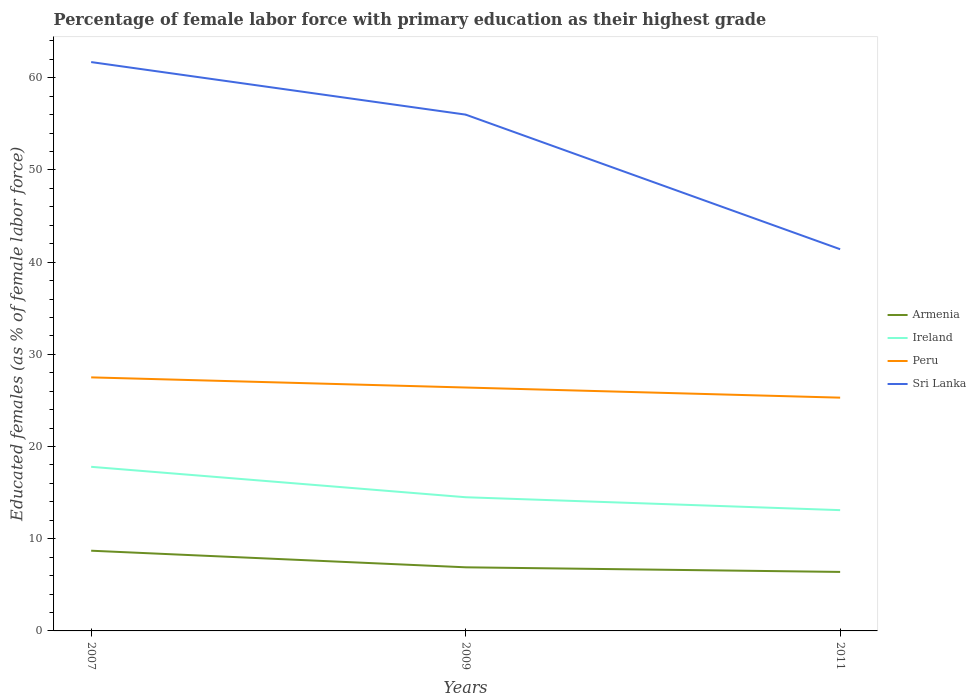Is the number of lines equal to the number of legend labels?
Your answer should be very brief. Yes. Across all years, what is the maximum percentage of female labor force with primary education in Ireland?
Provide a short and direct response. 13.1. What is the total percentage of female labor force with primary education in Sri Lanka in the graph?
Your answer should be very brief. 14.6. What is the difference between the highest and the second highest percentage of female labor force with primary education in Sri Lanka?
Your response must be concise. 20.3. How many years are there in the graph?
Offer a very short reply. 3. What is the difference between two consecutive major ticks on the Y-axis?
Provide a short and direct response. 10. Are the values on the major ticks of Y-axis written in scientific E-notation?
Your answer should be compact. No. Where does the legend appear in the graph?
Give a very brief answer. Center right. How are the legend labels stacked?
Make the answer very short. Vertical. What is the title of the graph?
Offer a terse response. Percentage of female labor force with primary education as their highest grade. Does "Somalia" appear as one of the legend labels in the graph?
Your answer should be compact. No. What is the label or title of the X-axis?
Ensure brevity in your answer.  Years. What is the label or title of the Y-axis?
Ensure brevity in your answer.  Educated females (as % of female labor force). What is the Educated females (as % of female labor force) in Armenia in 2007?
Offer a terse response. 8.7. What is the Educated females (as % of female labor force) of Ireland in 2007?
Ensure brevity in your answer.  17.8. What is the Educated females (as % of female labor force) of Peru in 2007?
Offer a terse response. 27.5. What is the Educated females (as % of female labor force) of Sri Lanka in 2007?
Provide a succinct answer. 61.7. What is the Educated females (as % of female labor force) in Armenia in 2009?
Offer a very short reply. 6.9. What is the Educated females (as % of female labor force) of Peru in 2009?
Your answer should be compact. 26.4. What is the Educated females (as % of female labor force) of Armenia in 2011?
Offer a very short reply. 6.4. What is the Educated females (as % of female labor force) in Ireland in 2011?
Provide a succinct answer. 13.1. What is the Educated females (as % of female labor force) of Peru in 2011?
Give a very brief answer. 25.3. What is the Educated females (as % of female labor force) in Sri Lanka in 2011?
Your response must be concise. 41.4. Across all years, what is the maximum Educated females (as % of female labor force) of Armenia?
Your response must be concise. 8.7. Across all years, what is the maximum Educated females (as % of female labor force) of Ireland?
Provide a short and direct response. 17.8. Across all years, what is the maximum Educated females (as % of female labor force) of Peru?
Make the answer very short. 27.5. Across all years, what is the maximum Educated females (as % of female labor force) in Sri Lanka?
Provide a short and direct response. 61.7. Across all years, what is the minimum Educated females (as % of female labor force) in Armenia?
Give a very brief answer. 6.4. Across all years, what is the minimum Educated females (as % of female labor force) of Ireland?
Make the answer very short. 13.1. Across all years, what is the minimum Educated females (as % of female labor force) of Peru?
Offer a terse response. 25.3. Across all years, what is the minimum Educated females (as % of female labor force) of Sri Lanka?
Keep it short and to the point. 41.4. What is the total Educated females (as % of female labor force) of Ireland in the graph?
Your response must be concise. 45.4. What is the total Educated females (as % of female labor force) of Peru in the graph?
Ensure brevity in your answer.  79.2. What is the total Educated females (as % of female labor force) in Sri Lanka in the graph?
Offer a very short reply. 159.1. What is the difference between the Educated females (as % of female labor force) in Armenia in 2007 and that in 2009?
Offer a terse response. 1.8. What is the difference between the Educated females (as % of female labor force) in Armenia in 2007 and that in 2011?
Your answer should be very brief. 2.3. What is the difference between the Educated females (as % of female labor force) in Ireland in 2007 and that in 2011?
Your answer should be very brief. 4.7. What is the difference between the Educated females (as % of female labor force) in Peru in 2007 and that in 2011?
Your answer should be compact. 2.2. What is the difference between the Educated females (as % of female labor force) in Sri Lanka in 2007 and that in 2011?
Provide a succinct answer. 20.3. What is the difference between the Educated females (as % of female labor force) of Armenia in 2009 and that in 2011?
Your answer should be compact. 0.5. What is the difference between the Educated females (as % of female labor force) in Peru in 2009 and that in 2011?
Give a very brief answer. 1.1. What is the difference between the Educated females (as % of female labor force) of Armenia in 2007 and the Educated females (as % of female labor force) of Peru in 2009?
Your answer should be compact. -17.7. What is the difference between the Educated females (as % of female labor force) of Armenia in 2007 and the Educated females (as % of female labor force) of Sri Lanka in 2009?
Make the answer very short. -47.3. What is the difference between the Educated females (as % of female labor force) in Ireland in 2007 and the Educated females (as % of female labor force) in Peru in 2009?
Offer a very short reply. -8.6. What is the difference between the Educated females (as % of female labor force) in Ireland in 2007 and the Educated females (as % of female labor force) in Sri Lanka in 2009?
Your answer should be very brief. -38.2. What is the difference between the Educated females (as % of female labor force) in Peru in 2007 and the Educated females (as % of female labor force) in Sri Lanka in 2009?
Ensure brevity in your answer.  -28.5. What is the difference between the Educated females (as % of female labor force) in Armenia in 2007 and the Educated females (as % of female labor force) in Ireland in 2011?
Provide a short and direct response. -4.4. What is the difference between the Educated females (as % of female labor force) in Armenia in 2007 and the Educated females (as % of female labor force) in Peru in 2011?
Provide a short and direct response. -16.6. What is the difference between the Educated females (as % of female labor force) of Armenia in 2007 and the Educated females (as % of female labor force) of Sri Lanka in 2011?
Provide a succinct answer. -32.7. What is the difference between the Educated females (as % of female labor force) of Ireland in 2007 and the Educated females (as % of female labor force) of Peru in 2011?
Give a very brief answer. -7.5. What is the difference between the Educated females (as % of female labor force) of Ireland in 2007 and the Educated females (as % of female labor force) of Sri Lanka in 2011?
Ensure brevity in your answer.  -23.6. What is the difference between the Educated females (as % of female labor force) in Armenia in 2009 and the Educated females (as % of female labor force) in Peru in 2011?
Your answer should be very brief. -18.4. What is the difference between the Educated females (as % of female labor force) of Armenia in 2009 and the Educated females (as % of female labor force) of Sri Lanka in 2011?
Make the answer very short. -34.5. What is the difference between the Educated females (as % of female labor force) of Ireland in 2009 and the Educated females (as % of female labor force) of Peru in 2011?
Ensure brevity in your answer.  -10.8. What is the difference between the Educated females (as % of female labor force) of Ireland in 2009 and the Educated females (as % of female labor force) of Sri Lanka in 2011?
Keep it short and to the point. -26.9. What is the average Educated females (as % of female labor force) of Armenia per year?
Keep it short and to the point. 7.33. What is the average Educated females (as % of female labor force) in Ireland per year?
Your answer should be very brief. 15.13. What is the average Educated females (as % of female labor force) in Peru per year?
Give a very brief answer. 26.4. What is the average Educated females (as % of female labor force) of Sri Lanka per year?
Keep it short and to the point. 53.03. In the year 2007, what is the difference between the Educated females (as % of female labor force) in Armenia and Educated females (as % of female labor force) in Ireland?
Give a very brief answer. -9.1. In the year 2007, what is the difference between the Educated females (as % of female labor force) of Armenia and Educated females (as % of female labor force) of Peru?
Your response must be concise. -18.8. In the year 2007, what is the difference between the Educated females (as % of female labor force) of Armenia and Educated females (as % of female labor force) of Sri Lanka?
Keep it short and to the point. -53. In the year 2007, what is the difference between the Educated females (as % of female labor force) of Ireland and Educated females (as % of female labor force) of Peru?
Provide a succinct answer. -9.7. In the year 2007, what is the difference between the Educated females (as % of female labor force) of Ireland and Educated females (as % of female labor force) of Sri Lanka?
Provide a short and direct response. -43.9. In the year 2007, what is the difference between the Educated females (as % of female labor force) of Peru and Educated females (as % of female labor force) of Sri Lanka?
Your answer should be very brief. -34.2. In the year 2009, what is the difference between the Educated females (as % of female labor force) of Armenia and Educated females (as % of female labor force) of Peru?
Your answer should be compact. -19.5. In the year 2009, what is the difference between the Educated females (as % of female labor force) of Armenia and Educated females (as % of female labor force) of Sri Lanka?
Your answer should be very brief. -49.1. In the year 2009, what is the difference between the Educated females (as % of female labor force) of Ireland and Educated females (as % of female labor force) of Sri Lanka?
Keep it short and to the point. -41.5. In the year 2009, what is the difference between the Educated females (as % of female labor force) of Peru and Educated females (as % of female labor force) of Sri Lanka?
Offer a very short reply. -29.6. In the year 2011, what is the difference between the Educated females (as % of female labor force) in Armenia and Educated females (as % of female labor force) in Peru?
Your answer should be very brief. -18.9. In the year 2011, what is the difference between the Educated females (as % of female labor force) in Armenia and Educated females (as % of female labor force) in Sri Lanka?
Your response must be concise. -35. In the year 2011, what is the difference between the Educated females (as % of female labor force) of Ireland and Educated females (as % of female labor force) of Peru?
Provide a succinct answer. -12.2. In the year 2011, what is the difference between the Educated females (as % of female labor force) in Ireland and Educated females (as % of female labor force) in Sri Lanka?
Your response must be concise. -28.3. In the year 2011, what is the difference between the Educated females (as % of female labor force) of Peru and Educated females (as % of female labor force) of Sri Lanka?
Ensure brevity in your answer.  -16.1. What is the ratio of the Educated females (as % of female labor force) in Armenia in 2007 to that in 2009?
Your response must be concise. 1.26. What is the ratio of the Educated females (as % of female labor force) of Ireland in 2007 to that in 2009?
Ensure brevity in your answer.  1.23. What is the ratio of the Educated females (as % of female labor force) in Peru in 2007 to that in 2009?
Provide a succinct answer. 1.04. What is the ratio of the Educated females (as % of female labor force) of Sri Lanka in 2007 to that in 2009?
Your answer should be very brief. 1.1. What is the ratio of the Educated females (as % of female labor force) of Armenia in 2007 to that in 2011?
Give a very brief answer. 1.36. What is the ratio of the Educated females (as % of female labor force) of Ireland in 2007 to that in 2011?
Offer a terse response. 1.36. What is the ratio of the Educated females (as % of female labor force) of Peru in 2007 to that in 2011?
Your answer should be very brief. 1.09. What is the ratio of the Educated females (as % of female labor force) in Sri Lanka in 2007 to that in 2011?
Provide a succinct answer. 1.49. What is the ratio of the Educated females (as % of female labor force) of Armenia in 2009 to that in 2011?
Make the answer very short. 1.08. What is the ratio of the Educated females (as % of female labor force) in Ireland in 2009 to that in 2011?
Provide a short and direct response. 1.11. What is the ratio of the Educated females (as % of female labor force) in Peru in 2009 to that in 2011?
Make the answer very short. 1.04. What is the ratio of the Educated females (as % of female labor force) in Sri Lanka in 2009 to that in 2011?
Your answer should be very brief. 1.35. What is the difference between the highest and the second highest Educated females (as % of female labor force) in Armenia?
Ensure brevity in your answer.  1.8. What is the difference between the highest and the second highest Educated females (as % of female labor force) in Peru?
Make the answer very short. 1.1. What is the difference between the highest and the lowest Educated females (as % of female labor force) in Sri Lanka?
Offer a terse response. 20.3. 